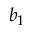<formula> <loc_0><loc_0><loc_500><loc_500>b _ { 1 }</formula> 